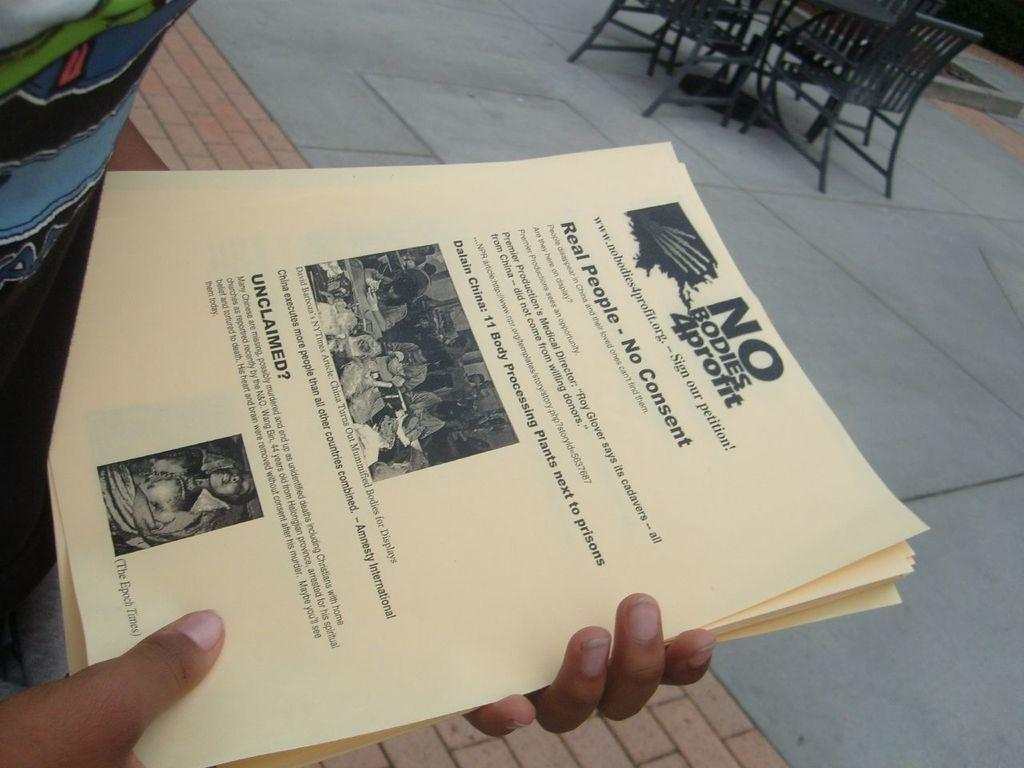<image>
Write a terse but informative summary of the picture. Body processing plants were a big news story at one time. 